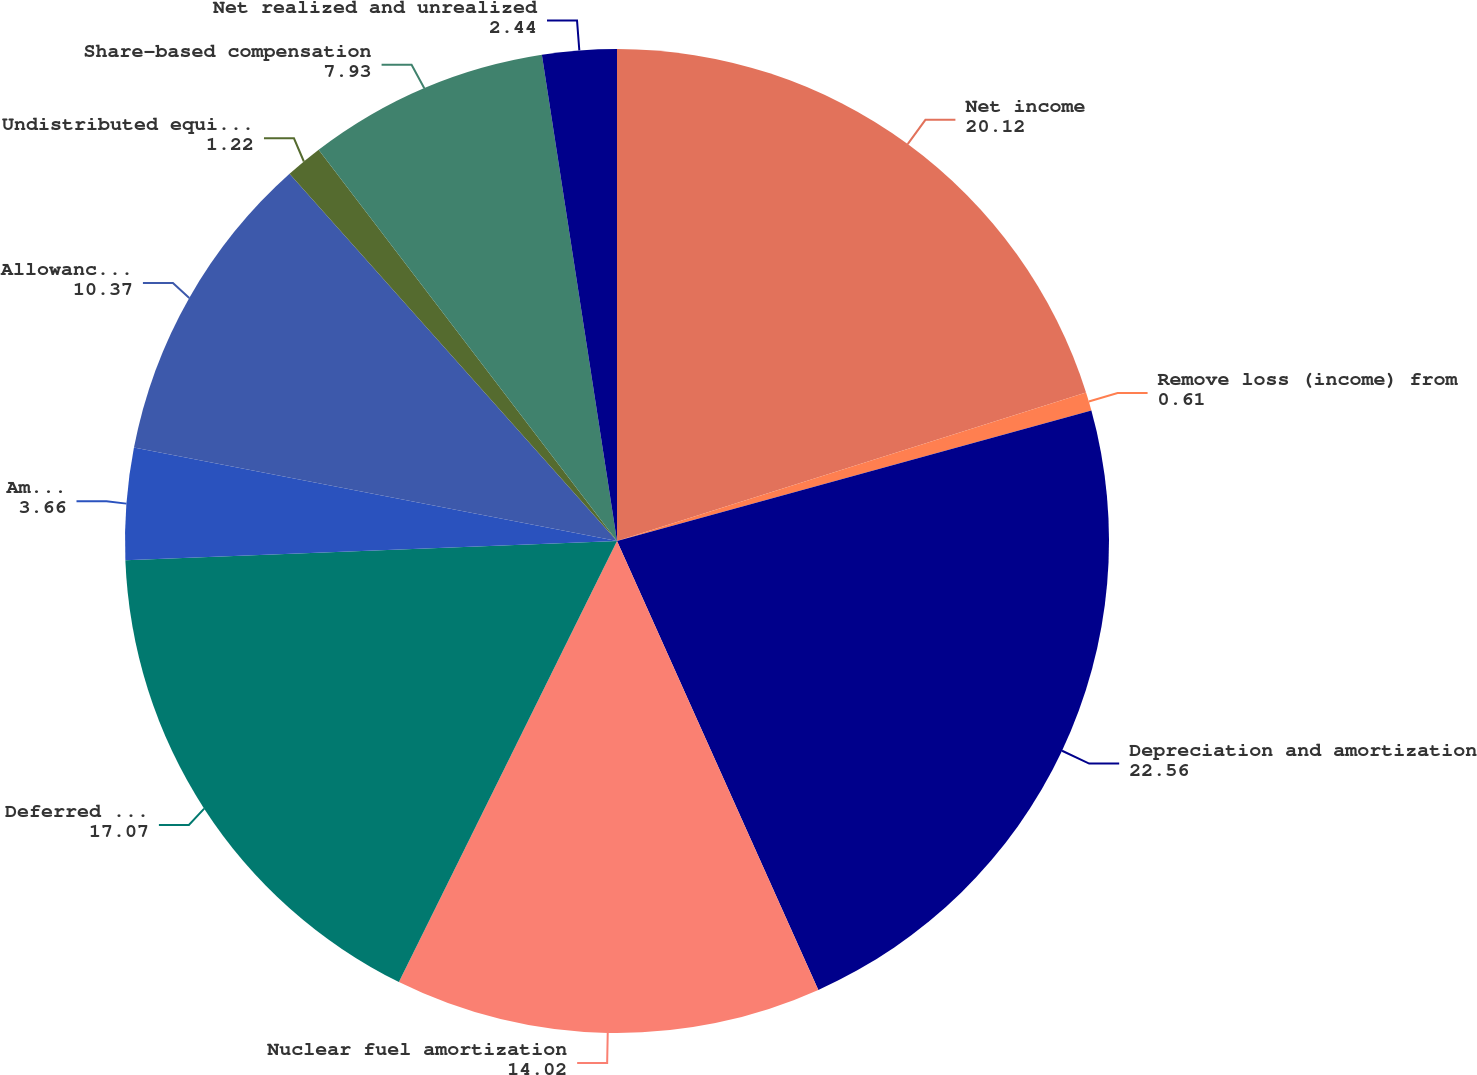Convert chart to OTSL. <chart><loc_0><loc_0><loc_500><loc_500><pie_chart><fcel>Net income<fcel>Remove loss (income) from<fcel>Depreciation and amortization<fcel>Nuclear fuel amortization<fcel>Deferred income taxes<fcel>Amortization of investment tax<fcel>Allowance for equity funds<fcel>Undistributed equity in<fcel>Share-based compensation<fcel>Net realized and unrealized<nl><fcel>20.12%<fcel>0.61%<fcel>22.56%<fcel>14.02%<fcel>17.07%<fcel>3.66%<fcel>10.37%<fcel>1.22%<fcel>7.93%<fcel>2.44%<nl></chart> 